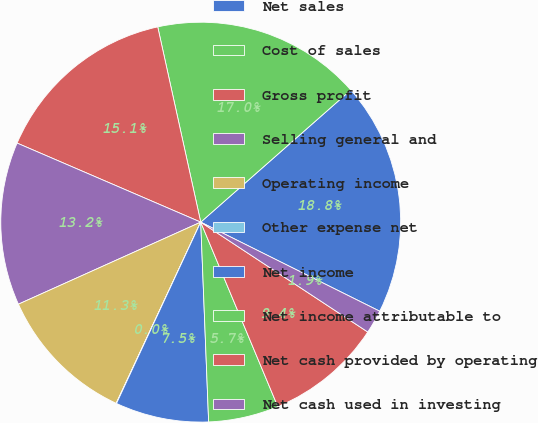<chart> <loc_0><loc_0><loc_500><loc_500><pie_chart><fcel>Net sales<fcel>Cost of sales<fcel>Gross profit<fcel>Selling general and<fcel>Operating income<fcel>Other expense net<fcel>Net income<fcel>Net income attributable to<fcel>Net cash provided by operating<fcel>Net cash used in investing<nl><fcel>18.84%<fcel>16.96%<fcel>15.08%<fcel>13.2%<fcel>11.32%<fcel>0.03%<fcel>7.55%<fcel>5.67%<fcel>9.44%<fcel>1.91%<nl></chart> 